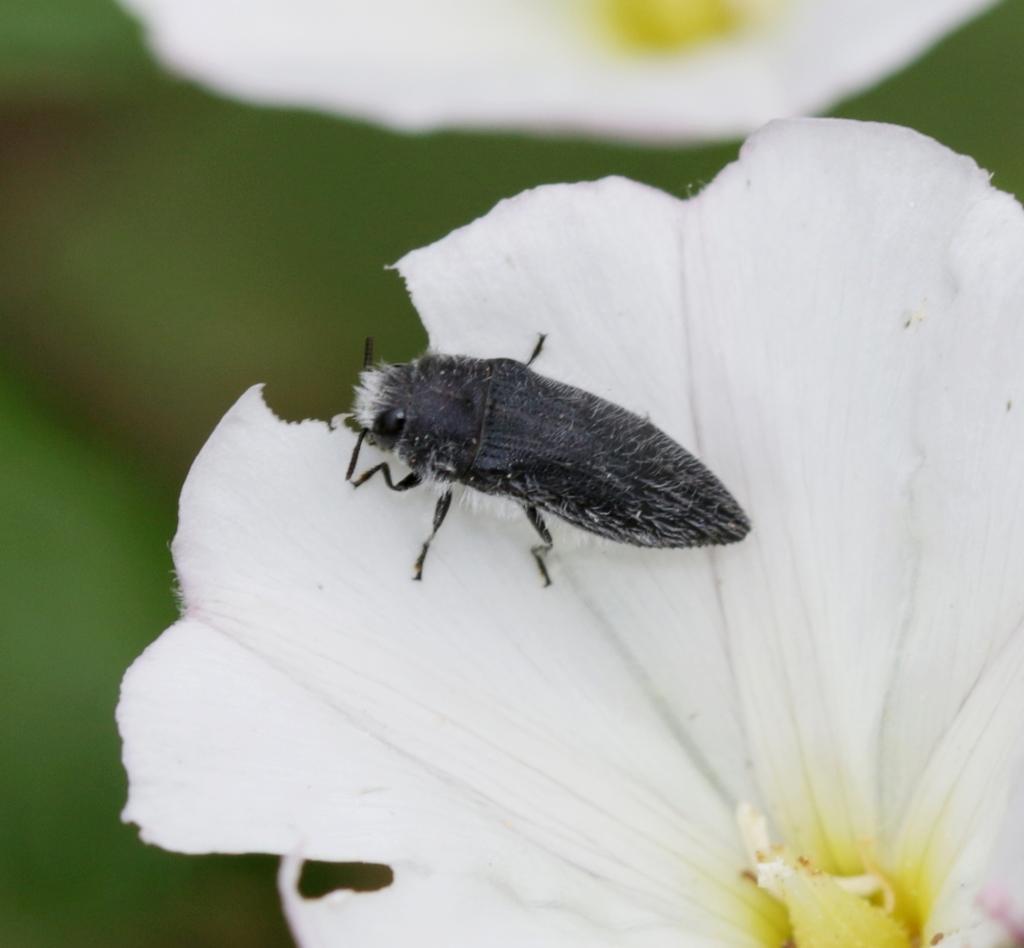Describe this image in one or two sentences. In this image there are two flowers. On the flower there is a bug. In the background there are leaves. The background is blurry. 